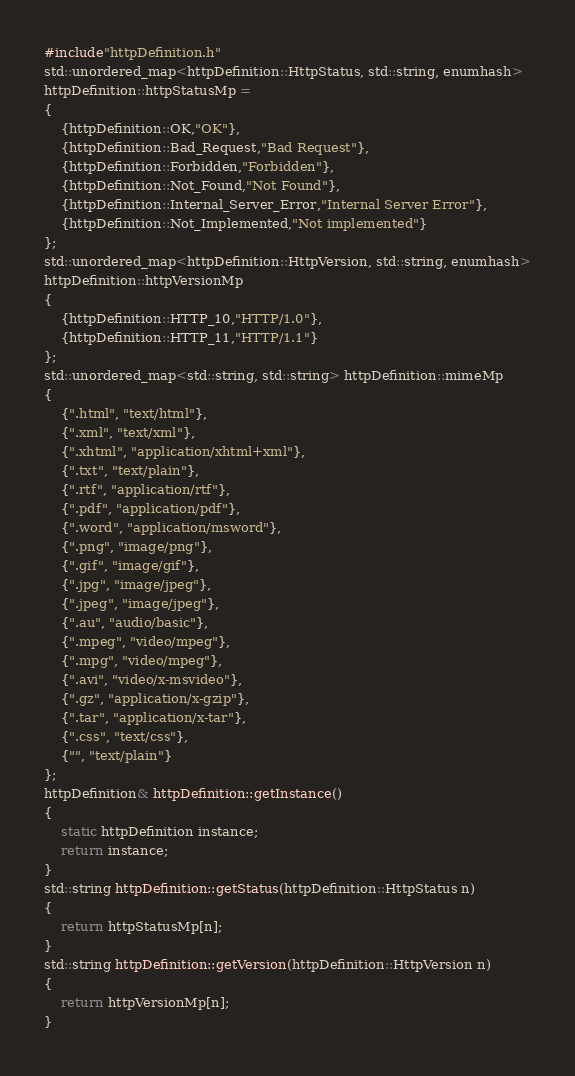Convert code to text. <code><loc_0><loc_0><loc_500><loc_500><_C++_>#include"httpDefinition.h"
std::unordered_map<httpDefinition::HttpStatus, std::string, enumhash>
httpDefinition::httpStatusMp =
{
    {httpDefinition::OK,"OK"},
    {httpDefinition::Bad_Request,"Bad Request"},
    {httpDefinition::Forbidden,"Forbidden"},
    {httpDefinition::Not_Found,"Not Found"},
    {httpDefinition::Internal_Server_Error,"Internal Server Error"},
    {httpDefinition::Not_Implemented,"Not implemented"}
};
std::unordered_map<httpDefinition::HttpVersion, std::string, enumhash>
httpDefinition::httpVersionMp
{
	{httpDefinition::HTTP_10,"HTTP/1.0"},
	{httpDefinition::HTTP_11,"HTTP/1.1"}
};
std::unordered_map<std::string, std::string> httpDefinition::mimeMp
{
    {".html", "text/html"},
    {".xml", "text/xml"},
    {".xhtml", "application/xhtml+xml"},
    {".txt", "text/plain"},
    {".rtf", "application/rtf"},
    {".pdf", "application/pdf"},
    {".word", "application/msword"},
    {".png", "image/png"},
    {".gif", "image/gif"},
    {".jpg", "image/jpeg"},
    {".jpeg", "image/jpeg"},
    {".au", "audio/basic"},
    {".mpeg", "video/mpeg"},
    {".mpg", "video/mpeg"},
    {".avi", "video/x-msvideo"},
    {".gz", "application/x-gzip"},
    {".tar", "application/x-tar"},
    {".css", "text/css"},
    {"", "text/plain"}
};
httpDefinition& httpDefinition::getInstance()
{
	static httpDefinition instance;
	return instance;
}
std::string httpDefinition::getStatus(httpDefinition::HttpStatus n)
{
	return httpStatusMp[n];
}
std::string httpDefinition::getVersion(httpDefinition::HttpVersion n)
{
	return httpVersionMp[n];
}

</code> 